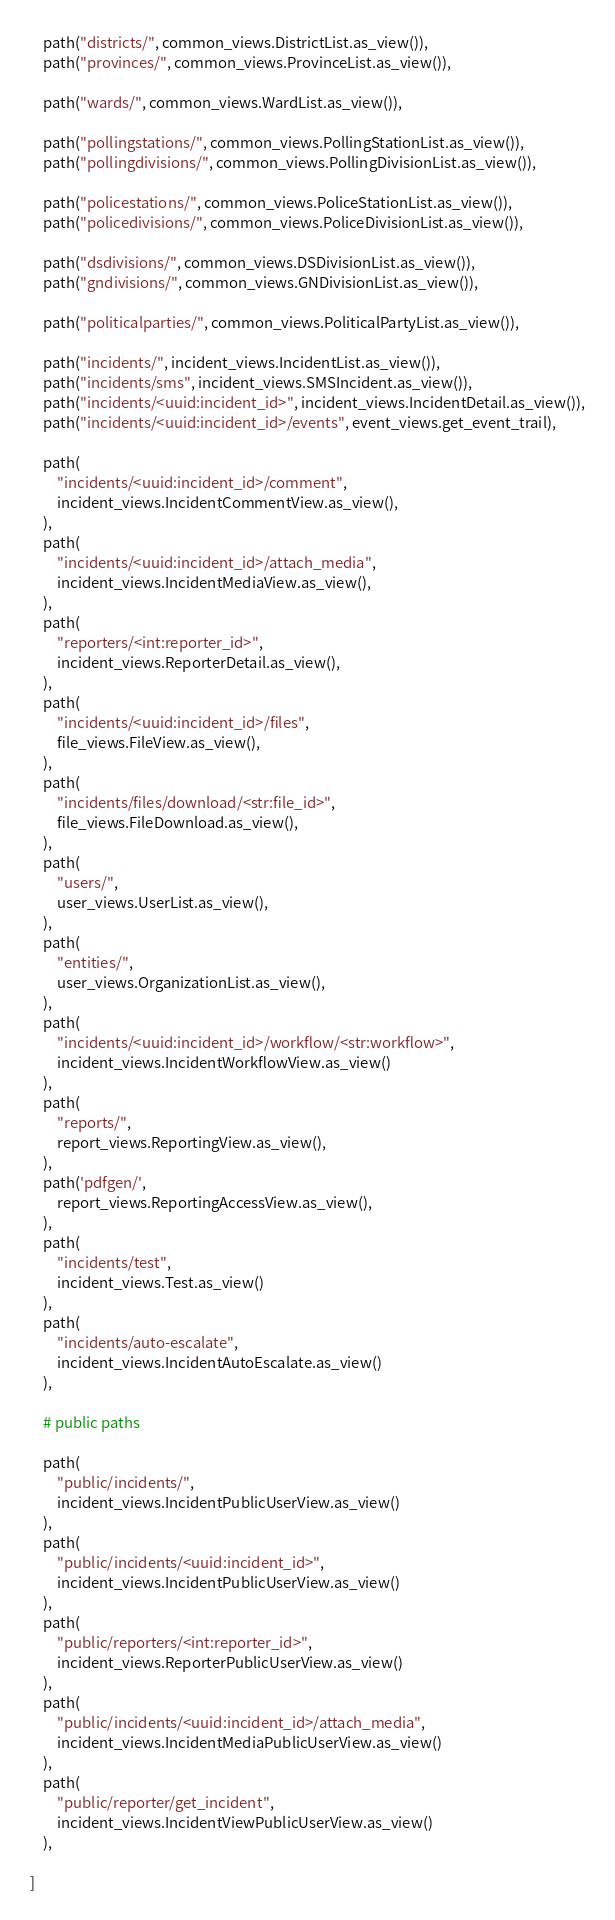Convert code to text. <code><loc_0><loc_0><loc_500><loc_500><_Python_>    path("districts/", common_views.DistrictList.as_view()),
    path("provinces/", common_views.ProvinceList.as_view()),
    
    path("wards/", common_views.WardList.as_view()),

    path("pollingstations/", common_views.PollingStationList.as_view()),
    path("pollingdivisions/", common_views.PollingDivisionList.as_view()),
    
    path("policestations/", common_views.PoliceStationList.as_view()),
    path("policedivisions/", common_views.PoliceDivisionList.as_view()),

    path("dsdivisions/", common_views.DSDivisionList.as_view()),
    path("gndivisions/", common_views.GNDivisionList.as_view()),

    path("politicalparties/", common_views.PoliticalPartyList.as_view()),

    path("incidents/", incident_views.IncidentList.as_view()),
    path("incidents/sms", incident_views.SMSIncident.as_view()),
    path("incidents/<uuid:incident_id>", incident_views.IncidentDetail.as_view()),
    path("incidents/<uuid:incident_id>/events", event_views.get_event_trail),
  
    path(
        "incidents/<uuid:incident_id>/comment",
        incident_views.IncidentCommentView.as_view(),
    ),
    path(
        "incidents/<uuid:incident_id>/attach_media",
        incident_views.IncidentMediaView.as_view(),
    ),
    path(
        "reporters/<int:reporter_id>", 
        incident_views.ReporterDetail.as_view(),
    ),
    path(
        "incidents/<uuid:incident_id>/files",
        file_views.FileView.as_view(),
    ),
    path(
        "incidents/files/download/<str:file_id>",
        file_views.FileDownload.as_view(),
    ),
    path(
        "users/",
        user_views.UserList.as_view(),
    ),
    path(
        "entities/",
        user_views.OrganizationList.as_view(),
    ),
    path(
        "incidents/<uuid:incident_id>/workflow/<str:workflow>",
        incident_views.IncidentWorkflowView.as_view()
    ),
    path(
        "reports/",
        report_views.ReportingView.as_view(),
    ),
    path('pdfgen/',
        report_views.ReportingAccessView.as_view(),
    ),
    path(
        "incidents/test",
        incident_views.Test.as_view()
    ),
    path(
        "incidents/auto-escalate",
        incident_views.IncidentAutoEscalate.as_view()
    ),

    # public paths

    path(
        "public/incidents/",
        incident_views.IncidentPublicUserView.as_view()
    ),
    path(
        "public/incidents/<uuid:incident_id>", 
        incident_views.IncidentPublicUserView.as_view()
    ),
    path(
        "public/reporters/<int:reporter_id>", 
        incident_views.ReporterPublicUserView.as_view()
    ),
    path(
        "public/incidents/<uuid:incident_id>/attach_media", 
        incident_views.IncidentMediaPublicUserView.as_view()
    ),
    path(
        "public/reporter/get_incident", 
        incident_views.IncidentViewPublicUserView.as_view()
    ),

]
</code> 